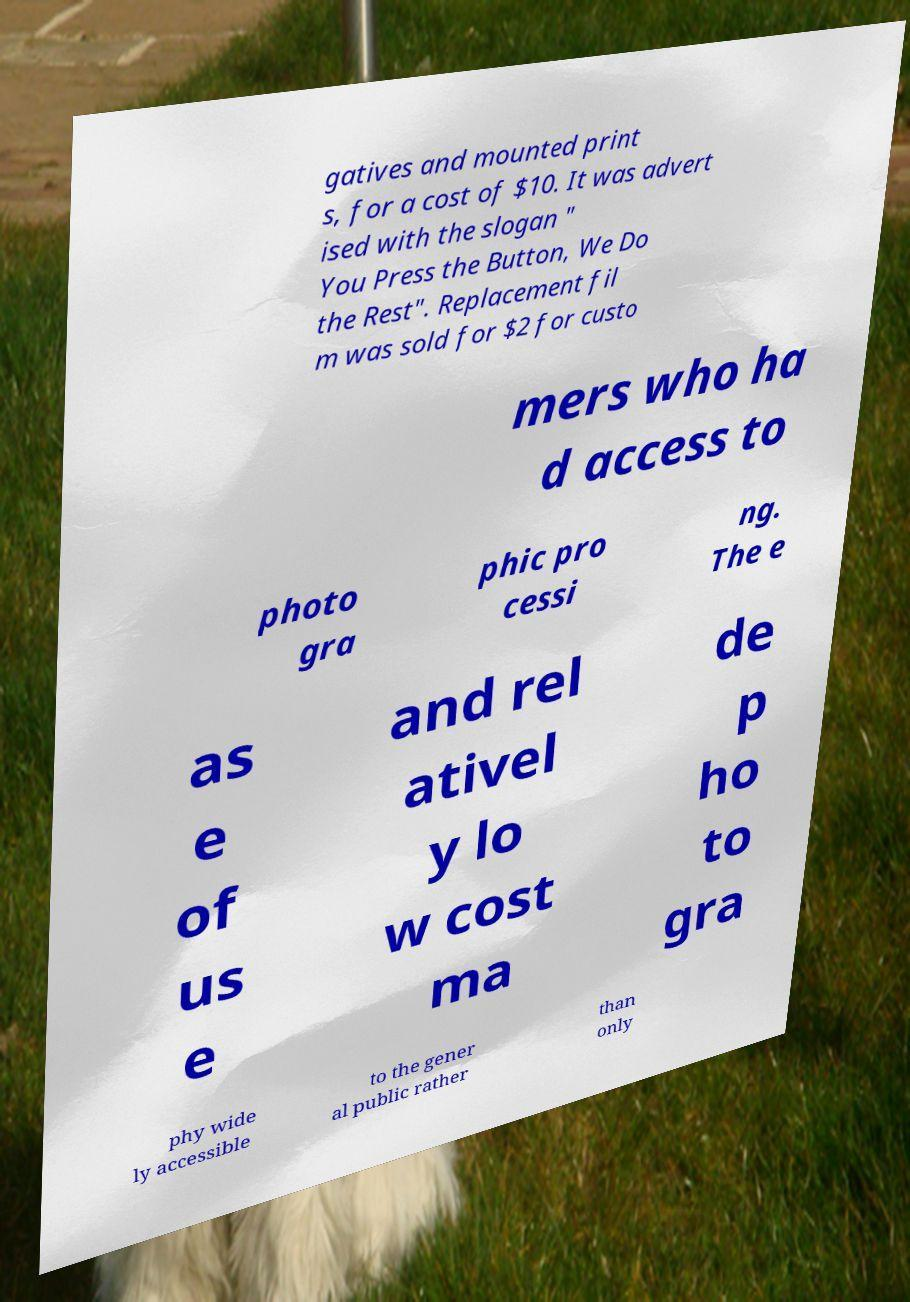Can you accurately transcribe the text from the provided image for me? gatives and mounted print s, for a cost of $10. It was advert ised with the slogan " You Press the Button, We Do the Rest". Replacement fil m was sold for $2 for custo mers who ha d access to photo gra phic pro cessi ng. The e as e of us e and rel ativel y lo w cost ma de p ho to gra phy wide ly accessible to the gener al public rather than only 